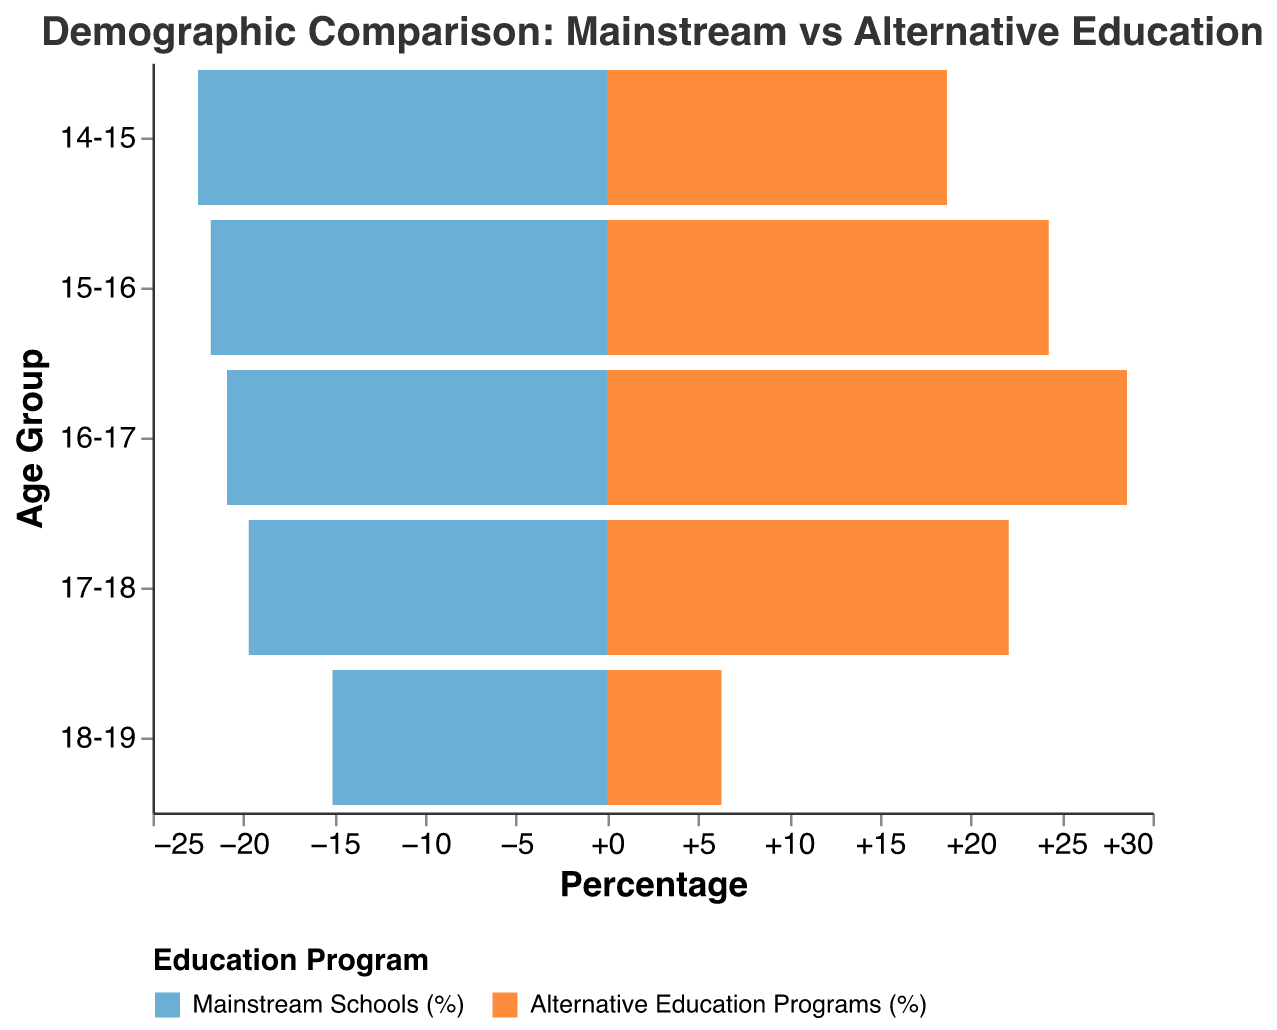What is the title of the figure? The title of the figure is displayed at the top and can be read directly. It is "Demographic Comparison: Mainstream vs Alternative Education".
Answer: Demographic Comparison: Mainstream vs Alternative Education What age group has the highest percentage in alternative education programs? The bar with the highest percentage in the alternative education programs section of the pyramid represents the age group 16-17.
Answer: 16-17 Compare the percentage of students aged 15-16 in mainstream schools and alternative education programs. For age group 15-16, compare the negative and positive values on the x-axis. In mainstream schools, it's 21.8%, and in alternative education, it's 24.3%.
Answer: 21.8% vs. 24.3% Which age group has the lowest representation in alternative education programs? Looking at the smallest positive bar (alternative education) on the x-axis, the age group 18-19 has the lowest representation at 6.3%.
Answer: 18-19 What is the average percentage of students aged 16-17 across both mainstream schools and alternative education programs? Compute the average using the percentages for 16-17: (20.9% + 28.6%) / 2 = 24.75%.
Answer: 24.75% How does the percentage of students aged 17-18 in mainstream schools compare to those in alternative education programs? The percentage for age group 17-18 in mainstream schools is 19.7%, while in alternative education programs, it is 22.1%. Compare these two numbers: 19.7% < 22.1%.
Answer: 19.7% < 22.1% What is the difference in percentage points between the age group 14-15 in mainstream schools and alternative education programs? Subtract the percentage for alternative education from the percentage for mainstream schools for age group 14-15: 22.5% - 18.7% = 3.8%.
Answer: 3.8% Identify the age group with nearly equal representation in both education programs. By comparing the values, the age group 17-18 has similar percentages in mainstream schools (19.7%) and alternative education programs (22.1%).
Answer: 17-18 What trend is observed in the representation of older students (age 18-19) in alternative education programs compared to mainstream schools? As students get older, the percentage representation of students aged 18-19 decreases significantly in alternative education programs (6.3%) compared to mainstream schools (15.1%).
Answer: Decreasing trend in alternative programs 